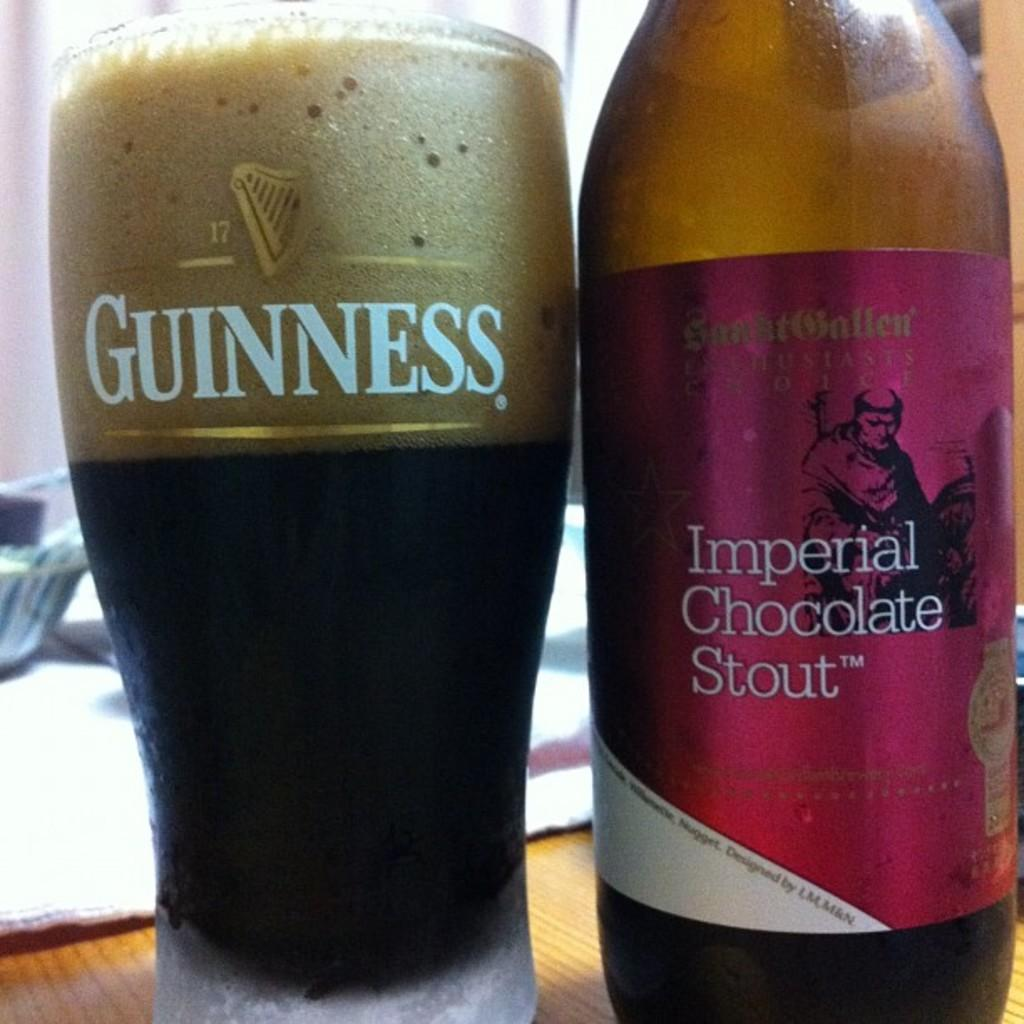Provide a one-sentence caption for the provided image. Imperial Chocolate Stout is best served in a Guinness glass. 